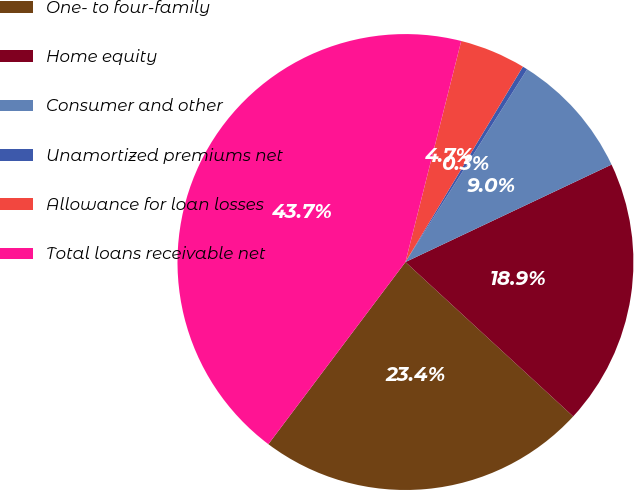Convert chart to OTSL. <chart><loc_0><loc_0><loc_500><loc_500><pie_chart><fcel>One- to four-family<fcel>Home equity<fcel>Consumer and other<fcel>Unamortized premiums net<fcel>Allowance for loan losses<fcel>Total loans receivable net<nl><fcel>23.43%<fcel>18.87%<fcel>9.01%<fcel>0.35%<fcel>4.68%<fcel>43.67%<nl></chart> 